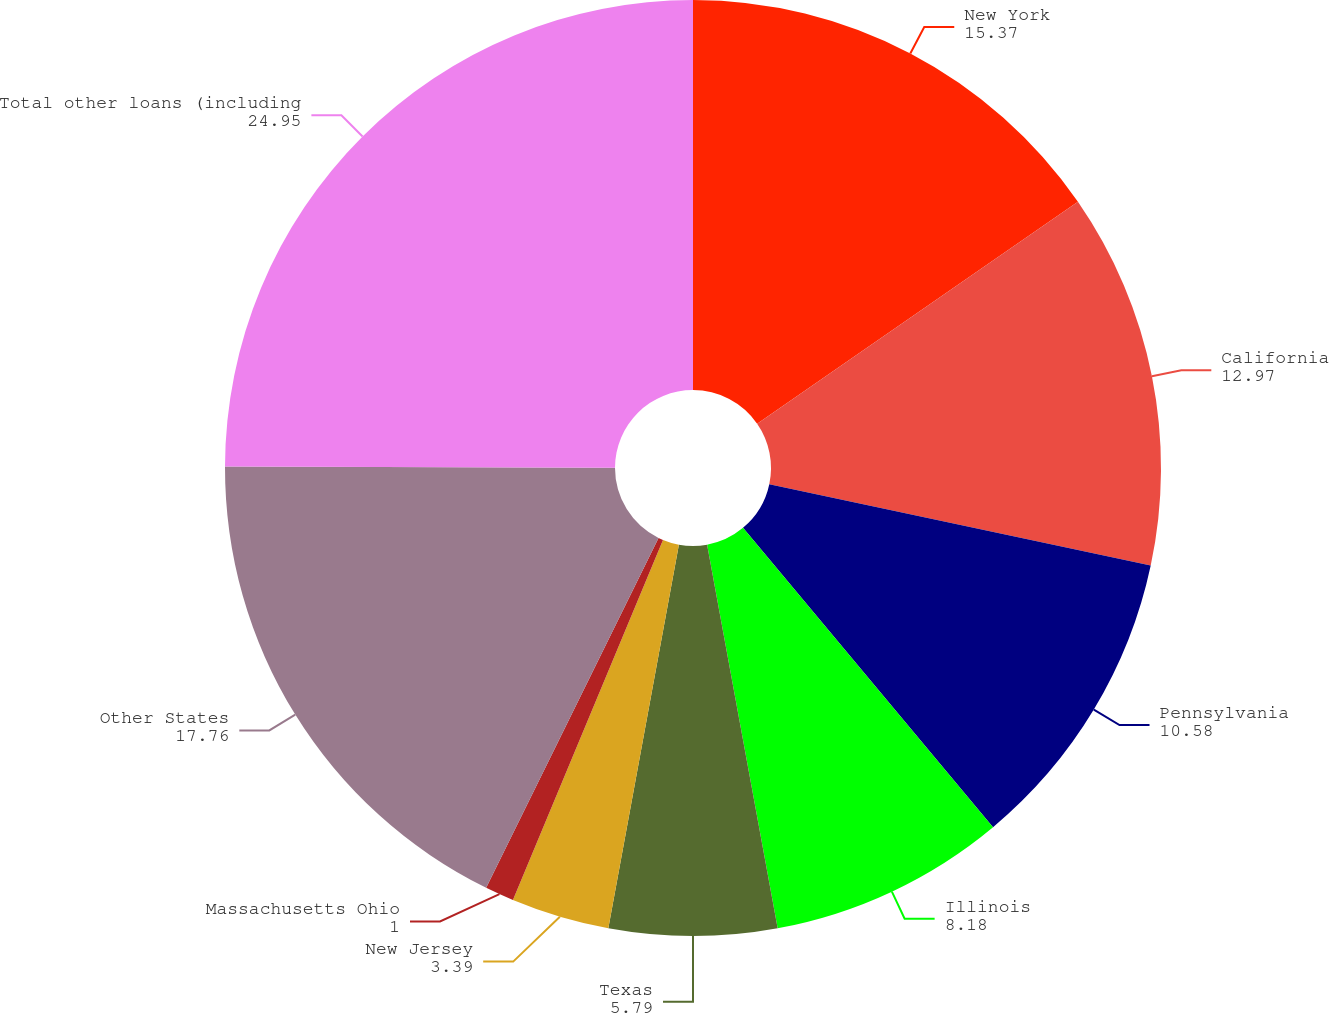Convert chart. <chart><loc_0><loc_0><loc_500><loc_500><pie_chart><fcel>New York<fcel>California<fcel>Pennsylvania<fcel>Illinois<fcel>Texas<fcel>New Jersey<fcel>Massachusetts Ohio<fcel>Other States<fcel>Total other loans (including<nl><fcel>15.37%<fcel>12.97%<fcel>10.58%<fcel>8.18%<fcel>5.79%<fcel>3.39%<fcel>1.0%<fcel>17.76%<fcel>24.95%<nl></chart> 